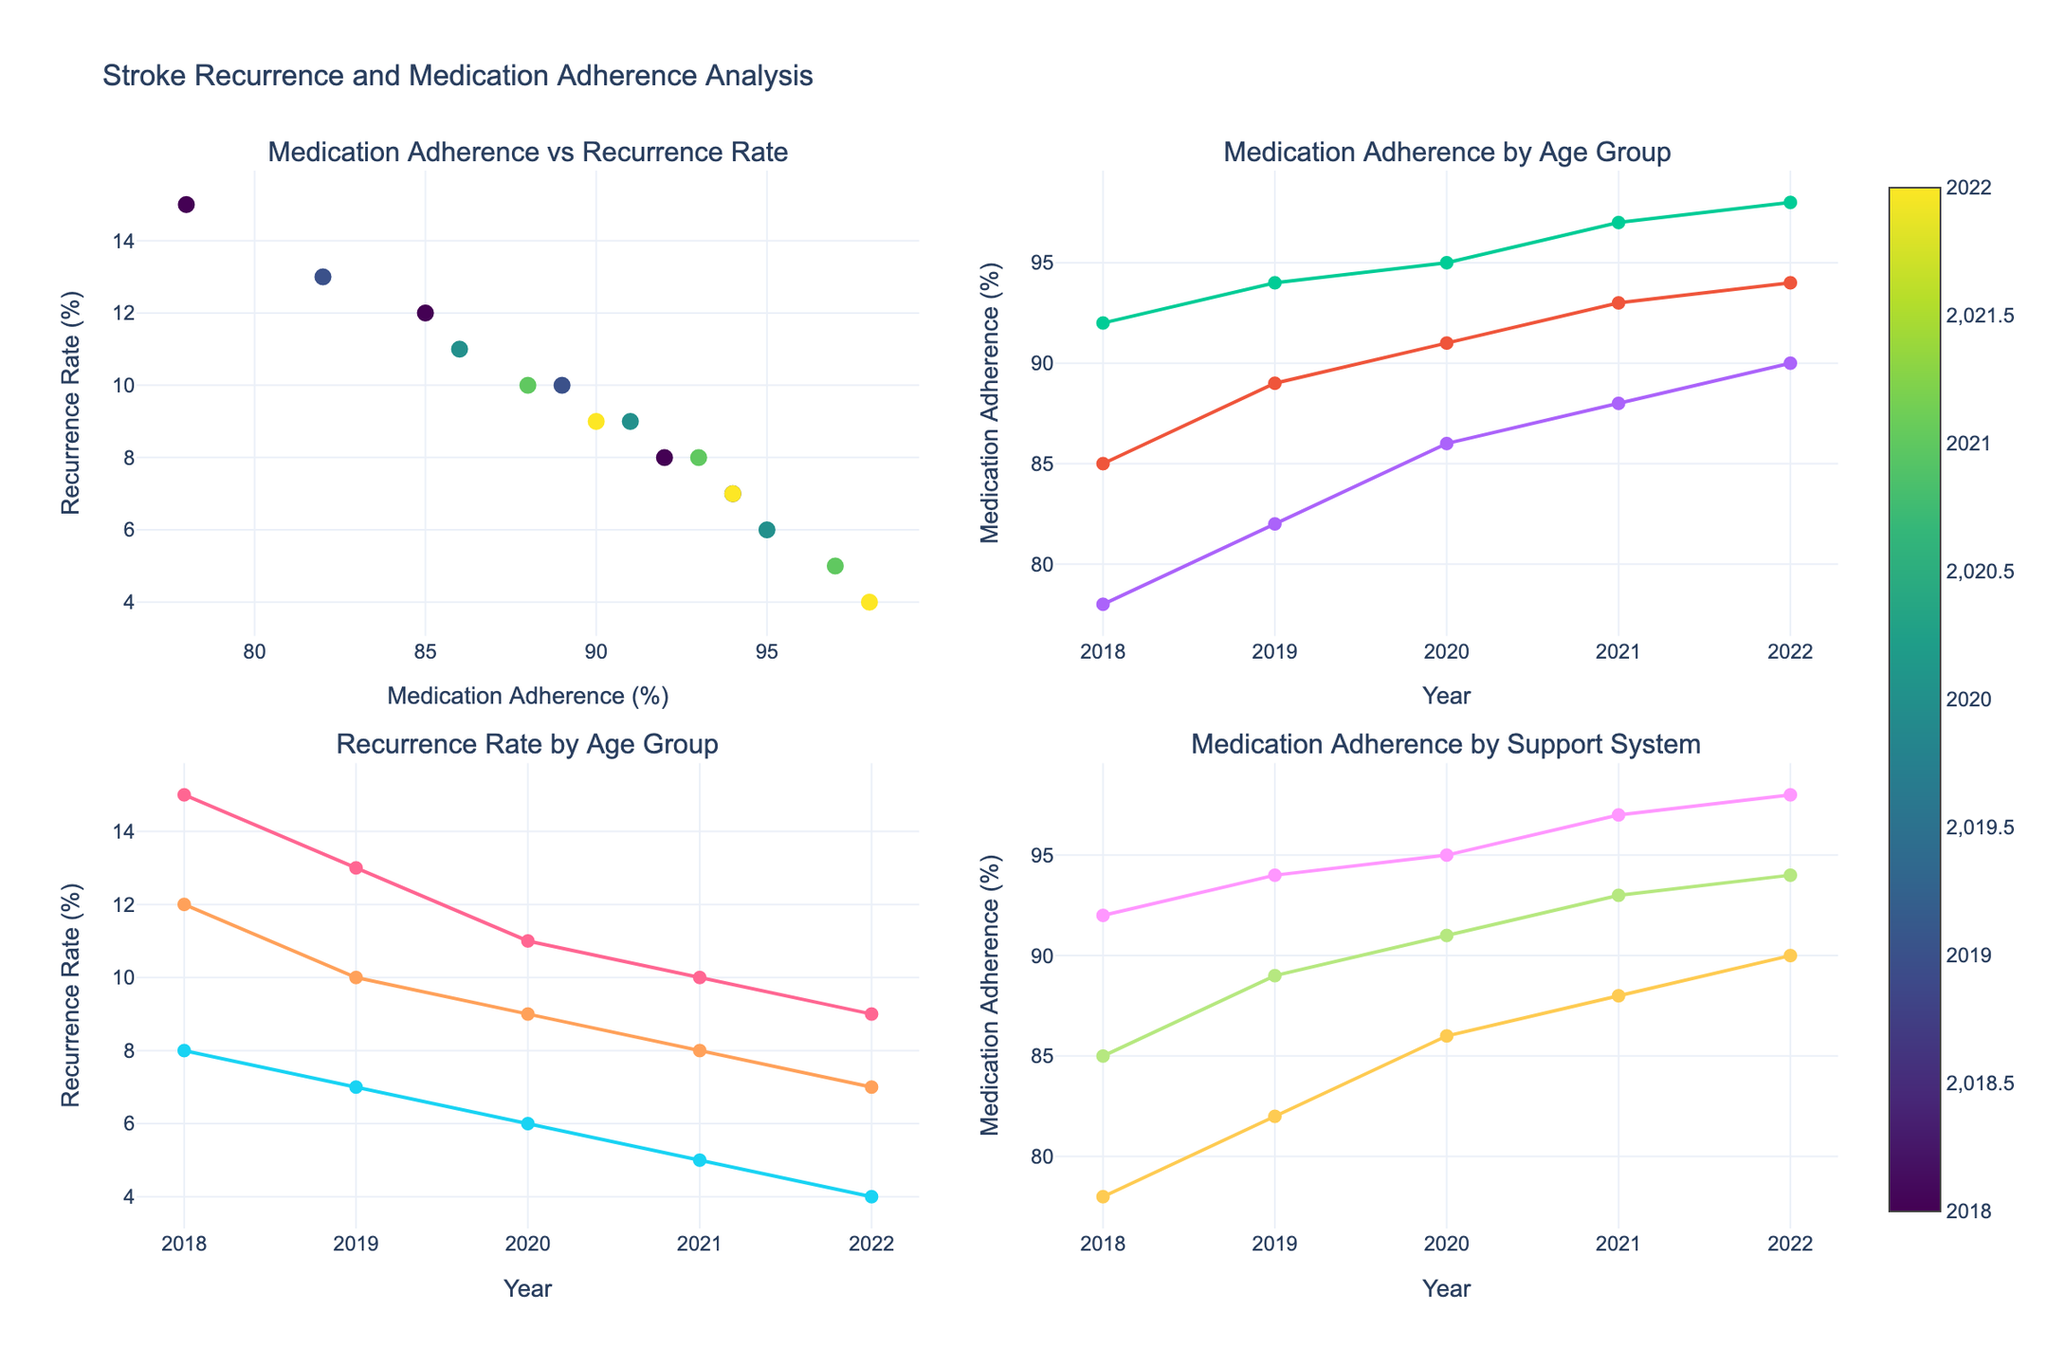How does medication adherence relate to stroke recurrence rates according to the plot? The scatter plot on the top left illustrates that as medication adherence increases, the recurrence rate generally decreases. By observing the trend, we can see lower recurrence rates are associated with higher adherence percentages across different years.
Answer: Higher adherence, lower recurrence Is there a trend in medication adherence for the age group 50-60 over time? In the top-right subplot which shows medication adherence by age group, the line representing the 50-60 age group consistently increases from 85% in 2018 to 94% in 2022, indicating a positive trend.
Answer: Increasing Which support system showed the highest medication adherence in 2022? In the bottom-right subplot, which depicts medication adherence by support system over the years, the 'Professional' support system reaches up to 98% adherence in 2022, the highest value among all support systems for that year.
Answer: Professional How does the recurrence rate for the 60-70 age group change over the years? In the bottom-left subplot, the line representing the recurrence rate for the 60-70 age group decreases from 8% in 2018 to 4% in 2022, showing a downward trend.
Answer: Decreasing Compare the medication adherence levels between the family support system and the community support system in 2020. In the bottom-right subplot, the 'Family' support system has a medication adherence level of 91% in 2020, whereas the 'Community' support system has an 86% adherence level for the same year.
Answer: Family: 91%, Community: 86% What is the relationship between the years and recurrence rates in the data shown for the age group 70-80? In the bottom-left subplot, the line for the 70-80 age group shows a fluctuating pattern, decreasing from 15% in 2018 to 9% in 2022 but with a small rise in 2019 and 2021.
Answer: Fluctuating Which year exhibited the lowest recurrence rate across all groups? Examining the scatter plot and the subplot for recurrence rate by age group, 2022 has the lowest recurrence rate at 4%.
Answer: 2022 How did the medication adherence of the 'Community' support system change from 2018 to 2022? The bottom-right subplot displays that the 'Community' support system's adherence rose from 78% in 2018 to 90% in 2022.
Answer: Increased What can you infer about trends in medication adherence over the years for all age groups in general? By looking at the top-right subplot, all age groups exhibit an upward trend in medication adherence over the years. This trend is most noticeable as all lines slope upward from 2018 to 2022.
Answer: Increasing for all groups 